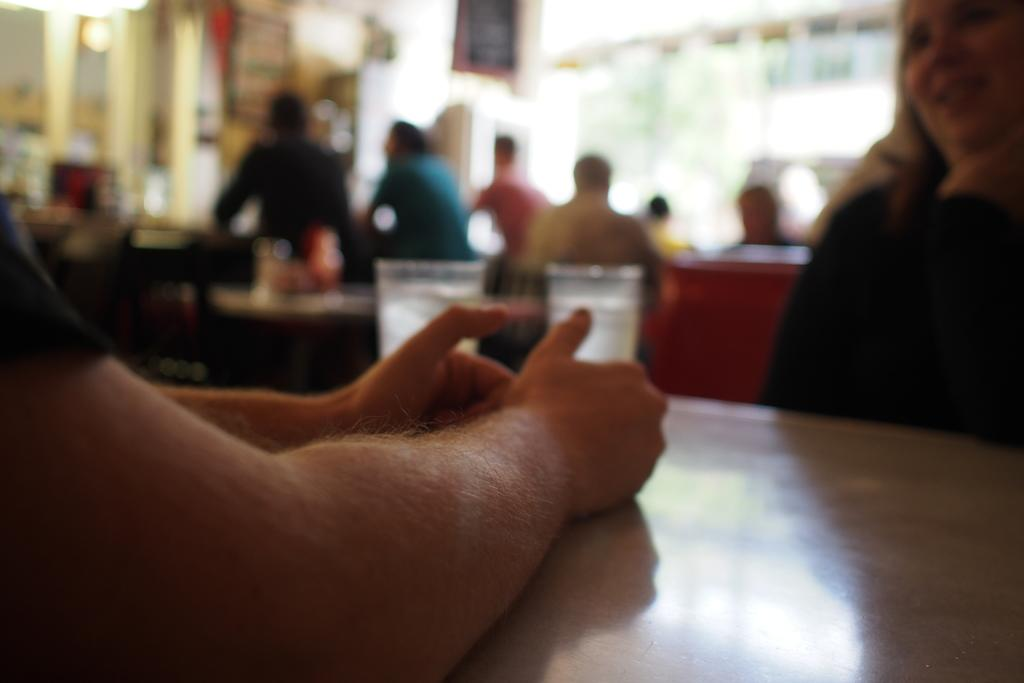What type of furniture is visible in the image? There are tables and chairs in the image. Can you describe the people in the image? There are people in the image, but their specific characteristics cannot be determined due to the blurry quality. What is located on the left side of the image? There are two hands on the left side of the image. How would you describe the overall clarity of the image? The image is blurry. What type of blood is visible on the tables in the image? There is no blood visible in the image; it only features tables, chairs, and people. What is the zephyr's role in the image? There is no zephyr present in the image. 